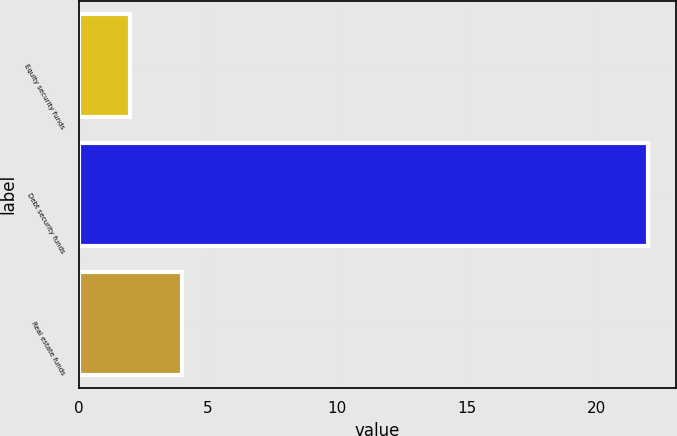Convert chart to OTSL. <chart><loc_0><loc_0><loc_500><loc_500><bar_chart><fcel>Equity security funds<fcel>Debt security funds<fcel>Real estate funds<nl><fcel>2<fcel>22<fcel>4<nl></chart> 